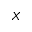<formula> <loc_0><loc_0><loc_500><loc_500>X</formula> 